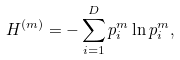<formula> <loc_0><loc_0><loc_500><loc_500>H ^ { ( m ) } = - \sum _ { i = 1 } ^ { D } p _ { i } ^ { m } \ln p _ { i } ^ { m } ,</formula> 